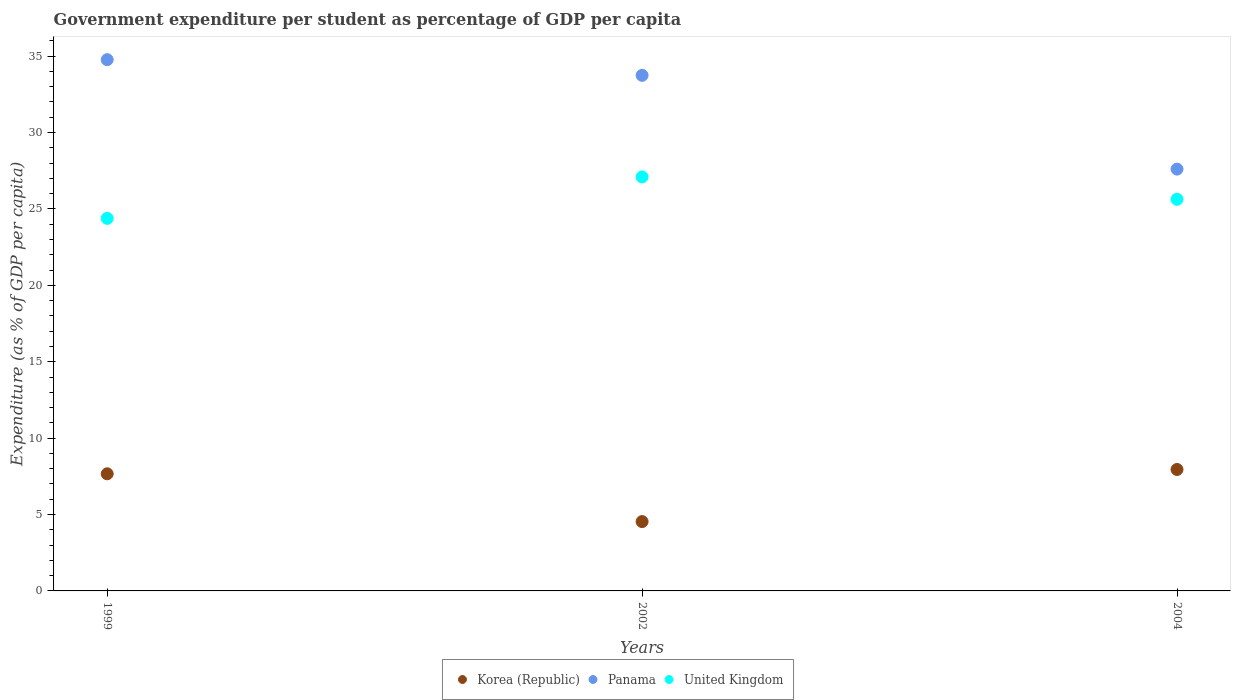How many different coloured dotlines are there?
Your answer should be compact. 3. What is the percentage of expenditure per student in Korea (Republic) in 2004?
Give a very brief answer. 7.95. Across all years, what is the maximum percentage of expenditure per student in Korea (Republic)?
Make the answer very short. 7.95. Across all years, what is the minimum percentage of expenditure per student in United Kingdom?
Make the answer very short. 24.38. What is the total percentage of expenditure per student in United Kingdom in the graph?
Provide a short and direct response. 77.11. What is the difference between the percentage of expenditure per student in Panama in 2002 and that in 2004?
Your answer should be very brief. 6.14. What is the difference between the percentage of expenditure per student in Panama in 2004 and the percentage of expenditure per student in Korea (Republic) in 2002?
Keep it short and to the point. 23.07. What is the average percentage of expenditure per student in Korea (Republic) per year?
Provide a short and direct response. 6.72. In the year 2004, what is the difference between the percentage of expenditure per student in United Kingdom and percentage of expenditure per student in Korea (Republic)?
Your answer should be very brief. 17.68. What is the ratio of the percentage of expenditure per student in United Kingdom in 1999 to that in 2002?
Offer a terse response. 0.9. Is the percentage of expenditure per student in United Kingdom in 1999 less than that in 2002?
Offer a very short reply. Yes. Is the difference between the percentage of expenditure per student in United Kingdom in 1999 and 2002 greater than the difference between the percentage of expenditure per student in Korea (Republic) in 1999 and 2002?
Provide a short and direct response. No. What is the difference between the highest and the second highest percentage of expenditure per student in Korea (Republic)?
Provide a succinct answer. 0.28. What is the difference between the highest and the lowest percentage of expenditure per student in United Kingdom?
Keep it short and to the point. 2.71. Is the sum of the percentage of expenditure per student in Korea (Republic) in 1999 and 2004 greater than the maximum percentage of expenditure per student in Panama across all years?
Provide a short and direct response. No. Is it the case that in every year, the sum of the percentage of expenditure per student in Panama and percentage of expenditure per student in United Kingdom  is greater than the percentage of expenditure per student in Korea (Republic)?
Ensure brevity in your answer.  Yes. Does the percentage of expenditure per student in United Kingdom monotonically increase over the years?
Offer a terse response. No. Is the percentage of expenditure per student in United Kingdom strictly greater than the percentage of expenditure per student in Korea (Republic) over the years?
Provide a short and direct response. Yes. Is the percentage of expenditure per student in Korea (Republic) strictly less than the percentage of expenditure per student in United Kingdom over the years?
Your response must be concise. Yes. How many years are there in the graph?
Provide a short and direct response. 3. Are the values on the major ticks of Y-axis written in scientific E-notation?
Provide a short and direct response. No. Does the graph contain any zero values?
Your answer should be very brief. No. Does the graph contain grids?
Offer a very short reply. No. Where does the legend appear in the graph?
Your answer should be compact. Bottom center. How many legend labels are there?
Give a very brief answer. 3. How are the legend labels stacked?
Your response must be concise. Horizontal. What is the title of the graph?
Provide a succinct answer. Government expenditure per student as percentage of GDP per capita. What is the label or title of the X-axis?
Provide a short and direct response. Years. What is the label or title of the Y-axis?
Your response must be concise. Expenditure (as % of GDP per capita). What is the Expenditure (as % of GDP per capita) of Korea (Republic) in 1999?
Offer a very short reply. 7.67. What is the Expenditure (as % of GDP per capita) in Panama in 1999?
Offer a very short reply. 34.77. What is the Expenditure (as % of GDP per capita) of United Kingdom in 1999?
Offer a very short reply. 24.38. What is the Expenditure (as % of GDP per capita) in Korea (Republic) in 2002?
Provide a succinct answer. 4.54. What is the Expenditure (as % of GDP per capita) of Panama in 2002?
Your response must be concise. 33.74. What is the Expenditure (as % of GDP per capita) of United Kingdom in 2002?
Offer a very short reply. 27.1. What is the Expenditure (as % of GDP per capita) in Korea (Republic) in 2004?
Make the answer very short. 7.95. What is the Expenditure (as % of GDP per capita) in Panama in 2004?
Give a very brief answer. 27.61. What is the Expenditure (as % of GDP per capita) of United Kingdom in 2004?
Your answer should be very brief. 25.63. Across all years, what is the maximum Expenditure (as % of GDP per capita) in Korea (Republic)?
Your response must be concise. 7.95. Across all years, what is the maximum Expenditure (as % of GDP per capita) of Panama?
Your answer should be very brief. 34.77. Across all years, what is the maximum Expenditure (as % of GDP per capita) in United Kingdom?
Your answer should be very brief. 27.1. Across all years, what is the minimum Expenditure (as % of GDP per capita) of Korea (Republic)?
Ensure brevity in your answer.  4.54. Across all years, what is the minimum Expenditure (as % of GDP per capita) in Panama?
Make the answer very short. 27.61. Across all years, what is the minimum Expenditure (as % of GDP per capita) in United Kingdom?
Your answer should be compact. 24.38. What is the total Expenditure (as % of GDP per capita) of Korea (Republic) in the graph?
Provide a short and direct response. 20.15. What is the total Expenditure (as % of GDP per capita) of Panama in the graph?
Your answer should be compact. 96.12. What is the total Expenditure (as % of GDP per capita) in United Kingdom in the graph?
Your answer should be very brief. 77.11. What is the difference between the Expenditure (as % of GDP per capita) of Korea (Republic) in 1999 and that in 2002?
Make the answer very short. 3.13. What is the difference between the Expenditure (as % of GDP per capita) in Panama in 1999 and that in 2002?
Make the answer very short. 1.03. What is the difference between the Expenditure (as % of GDP per capita) in United Kingdom in 1999 and that in 2002?
Give a very brief answer. -2.71. What is the difference between the Expenditure (as % of GDP per capita) in Korea (Republic) in 1999 and that in 2004?
Your answer should be very brief. -0.28. What is the difference between the Expenditure (as % of GDP per capita) of Panama in 1999 and that in 2004?
Keep it short and to the point. 7.16. What is the difference between the Expenditure (as % of GDP per capita) of United Kingdom in 1999 and that in 2004?
Ensure brevity in your answer.  -1.25. What is the difference between the Expenditure (as % of GDP per capita) of Korea (Republic) in 2002 and that in 2004?
Offer a terse response. -3.41. What is the difference between the Expenditure (as % of GDP per capita) of Panama in 2002 and that in 2004?
Offer a very short reply. 6.14. What is the difference between the Expenditure (as % of GDP per capita) in United Kingdom in 2002 and that in 2004?
Your answer should be compact. 1.47. What is the difference between the Expenditure (as % of GDP per capita) of Korea (Republic) in 1999 and the Expenditure (as % of GDP per capita) of Panama in 2002?
Your answer should be compact. -26.08. What is the difference between the Expenditure (as % of GDP per capita) of Korea (Republic) in 1999 and the Expenditure (as % of GDP per capita) of United Kingdom in 2002?
Offer a terse response. -19.43. What is the difference between the Expenditure (as % of GDP per capita) in Panama in 1999 and the Expenditure (as % of GDP per capita) in United Kingdom in 2002?
Your response must be concise. 7.67. What is the difference between the Expenditure (as % of GDP per capita) in Korea (Republic) in 1999 and the Expenditure (as % of GDP per capita) in Panama in 2004?
Provide a succinct answer. -19.94. What is the difference between the Expenditure (as % of GDP per capita) in Korea (Republic) in 1999 and the Expenditure (as % of GDP per capita) in United Kingdom in 2004?
Provide a succinct answer. -17.96. What is the difference between the Expenditure (as % of GDP per capita) of Panama in 1999 and the Expenditure (as % of GDP per capita) of United Kingdom in 2004?
Your response must be concise. 9.14. What is the difference between the Expenditure (as % of GDP per capita) in Korea (Republic) in 2002 and the Expenditure (as % of GDP per capita) in Panama in 2004?
Keep it short and to the point. -23.07. What is the difference between the Expenditure (as % of GDP per capita) in Korea (Republic) in 2002 and the Expenditure (as % of GDP per capita) in United Kingdom in 2004?
Provide a short and direct response. -21.09. What is the difference between the Expenditure (as % of GDP per capita) in Panama in 2002 and the Expenditure (as % of GDP per capita) in United Kingdom in 2004?
Offer a very short reply. 8.11. What is the average Expenditure (as % of GDP per capita) in Korea (Republic) per year?
Provide a short and direct response. 6.72. What is the average Expenditure (as % of GDP per capita) in Panama per year?
Provide a succinct answer. 32.04. What is the average Expenditure (as % of GDP per capita) in United Kingdom per year?
Your answer should be very brief. 25.7. In the year 1999, what is the difference between the Expenditure (as % of GDP per capita) of Korea (Republic) and Expenditure (as % of GDP per capita) of Panama?
Make the answer very short. -27.1. In the year 1999, what is the difference between the Expenditure (as % of GDP per capita) in Korea (Republic) and Expenditure (as % of GDP per capita) in United Kingdom?
Your response must be concise. -16.72. In the year 1999, what is the difference between the Expenditure (as % of GDP per capita) in Panama and Expenditure (as % of GDP per capita) in United Kingdom?
Your response must be concise. 10.39. In the year 2002, what is the difference between the Expenditure (as % of GDP per capita) in Korea (Republic) and Expenditure (as % of GDP per capita) in Panama?
Provide a short and direct response. -29.2. In the year 2002, what is the difference between the Expenditure (as % of GDP per capita) of Korea (Republic) and Expenditure (as % of GDP per capita) of United Kingdom?
Give a very brief answer. -22.56. In the year 2002, what is the difference between the Expenditure (as % of GDP per capita) in Panama and Expenditure (as % of GDP per capita) in United Kingdom?
Offer a terse response. 6.65. In the year 2004, what is the difference between the Expenditure (as % of GDP per capita) in Korea (Republic) and Expenditure (as % of GDP per capita) in Panama?
Keep it short and to the point. -19.66. In the year 2004, what is the difference between the Expenditure (as % of GDP per capita) of Korea (Republic) and Expenditure (as % of GDP per capita) of United Kingdom?
Provide a succinct answer. -17.68. In the year 2004, what is the difference between the Expenditure (as % of GDP per capita) in Panama and Expenditure (as % of GDP per capita) in United Kingdom?
Give a very brief answer. 1.98. What is the ratio of the Expenditure (as % of GDP per capita) of Korea (Republic) in 1999 to that in 2002?
Provide a succinct answer. 1.69. What is the ratio of the Expenditure (as % of GDP per capita) in Panama in 1999 to that in 2002?
Your answer should be compact. 1.03. What is the ratio of the Expenditure (as % of GDP per capita) in United Kingdom in 1999 to that in 2002?
Offer a terse response. 0.9. What is the ratio of the Expenditure (as % of GDP per capita) of Korea (Republic) in 1999 to that in 2004?
Provide a short and direct response. 0.96. What is the ratio of the Expenditure (as % of GDP per capita) of Panama in 1999 to that in 2004?
Your response must be concise. 1.26. What is the ratio of the Expenditure (as % of GDP per capita) of United Kingdom in 1999 to that in 2004?
Offer a terse response. 0.95. What is the ratio of the Expenditure (as % of GDP per capita) of Korea (Republic) in 2002 to that in 2004?
Your response must be concise. 0.57. What is the ratio of the Expenditure (as % of GDP per capita) in Panama in 2002 to that in 2004?
Offer a terse response. 1.22. What is the ratio of the Expenditure (as % of GDP per capita) of United Kingdom in 2002 to that in 2004?
Keep it short and to the point. 1.06. What is the difference between the highest and the second highest Expenditure (as % of GDP per capita) in Korea (Republic)?
Provide a succinct answer. 0.28. What is the difference between the highest and the second highest Expenditure (as % of GDP per capita) in Panama?
Your response must be concise. 1.03. What is the difference between the highest and the second highest Expenditure (as % of GDP per capita) of United Kingdom?
Your response must be concise. 1.47. What is the difference between the highest and the lowest Expenditure (as % of GDP per capita) of Korea (Republic)?
Offer a terse response. 3.41. What is the difference between the highest and the lowest Expenditure (as % of GDP per capita) in Panama?
Provide a short and direct response. 7.16. What is the difference between the highest and the lowest Expenditure (as % of GDP per capita) of United Kingdom?
Offer a very short reply. 2.71. 